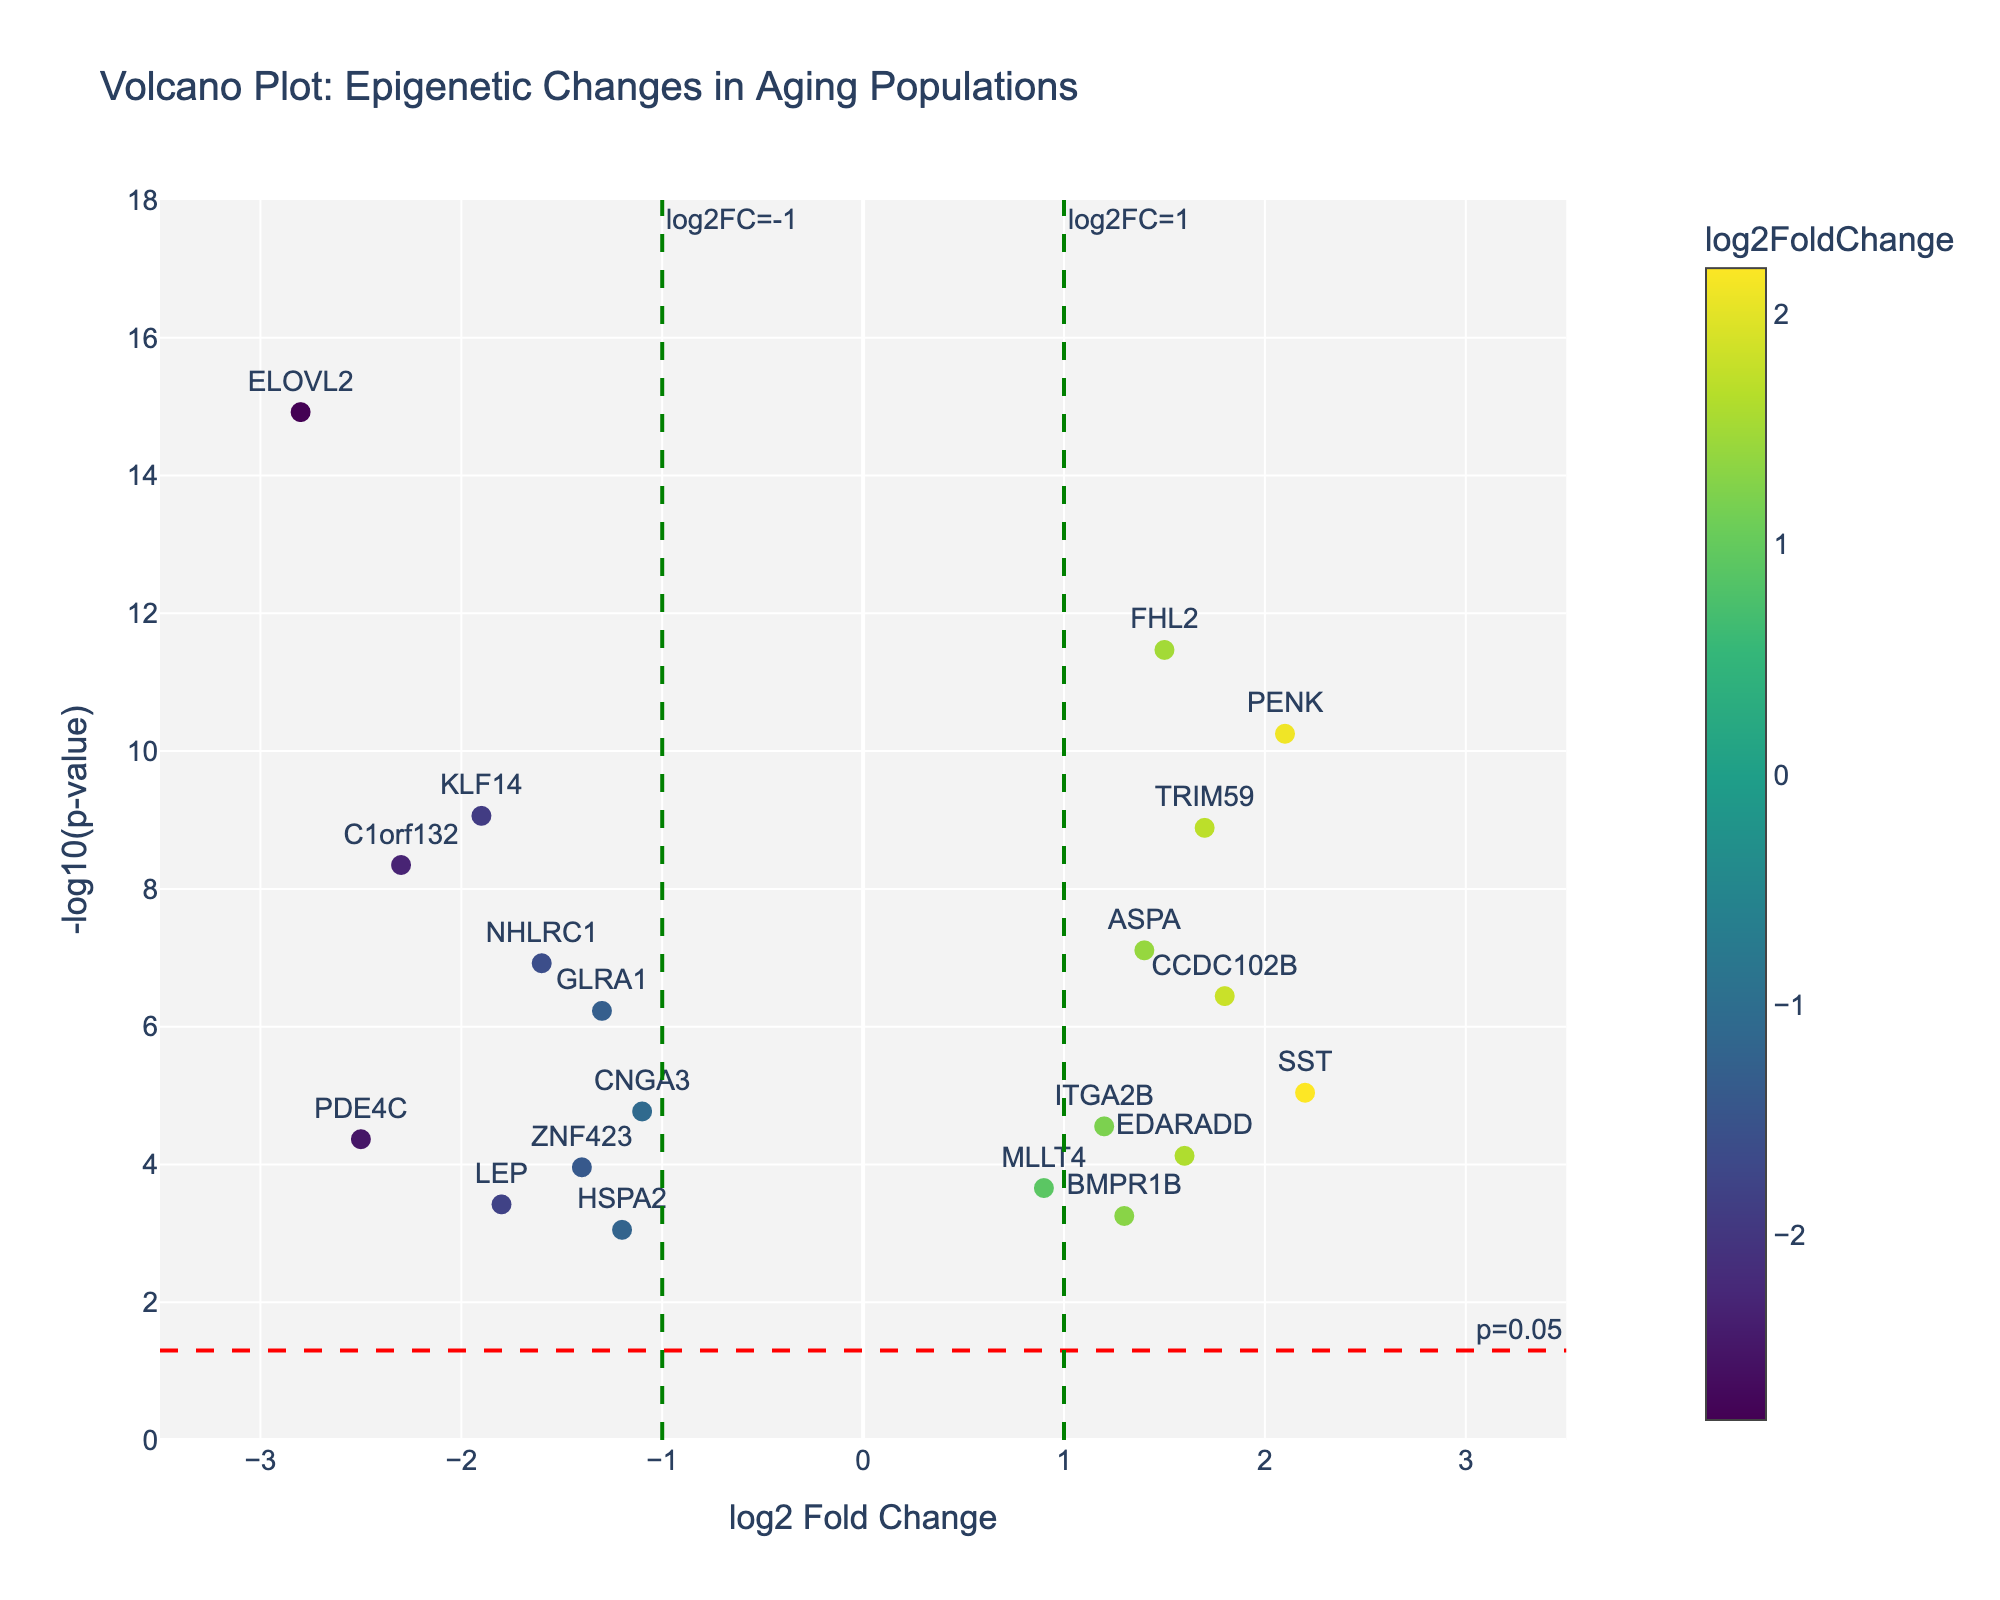How many genes are represented in the Volcano Plot? To determine the number of genes, count the number of unique gene names in the dataset.
Answer: 20 What is the y-axis title of the Volcano Plot? The y-axis title is displayed on the left side of the plot, indicating the type of data represented.
Answer: -log10(p-value) Which gene has the highest negative log2 fold change? Identify the gene with the lowest log2 fold change value by comparing all the values. "ELOVL2" has the largest negative value at -2.8.
Answer: ELOVL2 What are the colors used in the scatter plot? The colors used in the scatter plot are part of a Viridis color scale, which ranges from shades of purple to yellow depending on the log2 fold change value.
Answer: Shades of purple to yellow What does the red horizontal dashed line represent? The red dashed line sets a threshold for the p-value; specifically, it represents a p-value cutoff of 0.05, shown as -log10(0.05).
Answer: p=0.05 Which gene has the highest -log10(p-value) and what is its value? To find the gene with the highest -log10(p-value), look for the gene at the top of the y-axis. "ELOVL2" has the highest -log10(p-value) with a value of -log10(1.2e-15) ≈ 15.92.
Answer: ELOVL2, 15.92 How many genes have a log2 fold change greater than 1? To determine this, count the number of genes with log2 fold change values greater than 1.
Answer: 6 Which gene has a log2 fold change of approximately 2.1 and what is its p-value? Locate the gene corresponding to a log2 fold change of around 2.1. "PENK" has a log2 fold change of 2.1 with a p-value of 5.6e-11.
Answer: PENK, 5.6e-11 What is the range of the x-axis values? The x-axis range indicates the minimum and maximum values for log2 fold change displayed in the plot. It spans from -3.5 to 3.5, as specified.
Answer: -3.5 to 3.5 Which genes exceed the threshold lines for both log2 fold change and p-value? Identify genes that have log2 fold changes >1 or <-1 and -log10(p-values) above the red horizontal dashed line (p=0.05). That's genes "ELOVL2", "FHL2", "PENK", "KLF14", "TRIM59", "C1orf132", and "PDE4C".
Answer: ELOVL2, FHL2, PENK, KLF14, TRIM59, C1orf132, PDE4C 